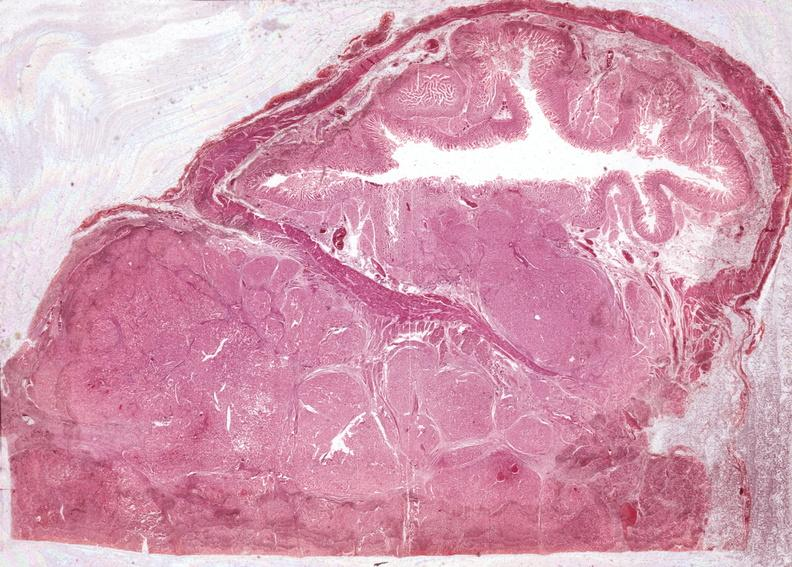s immunoblastic type cells near splenic arteriole man present?
Answer the question using a single word or phrase. No 